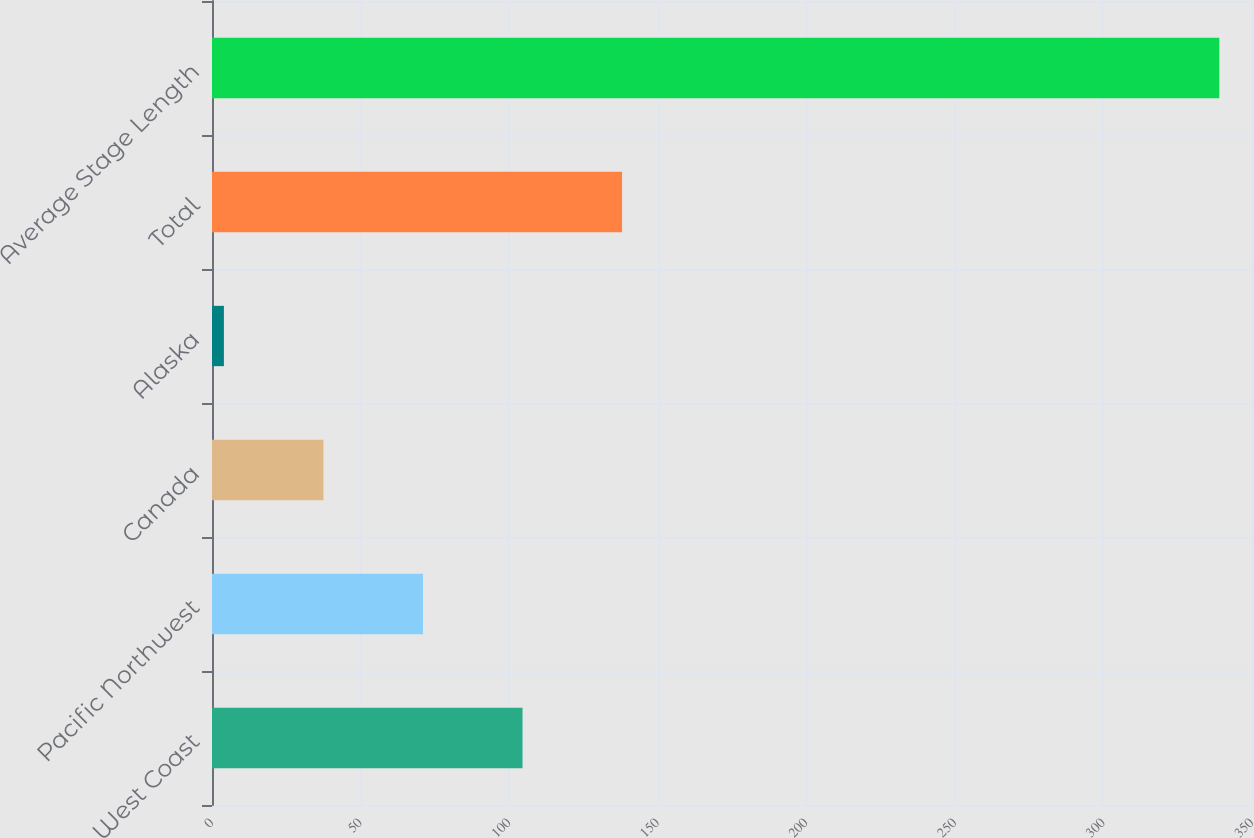Convert chart. <chart><loc_0><loc_0><loc_500><loc_500><bar_chart><fcel>West Coast<fcel>Pacific Northwest<fcel>Canada<fcel>Alaska<fcel>Total<fcel>Average Stage Length<nl><fcel>104.5<fcel>71<fcel>37.5<fcel>4<fcel>138<fcel>339<nl></chart> 